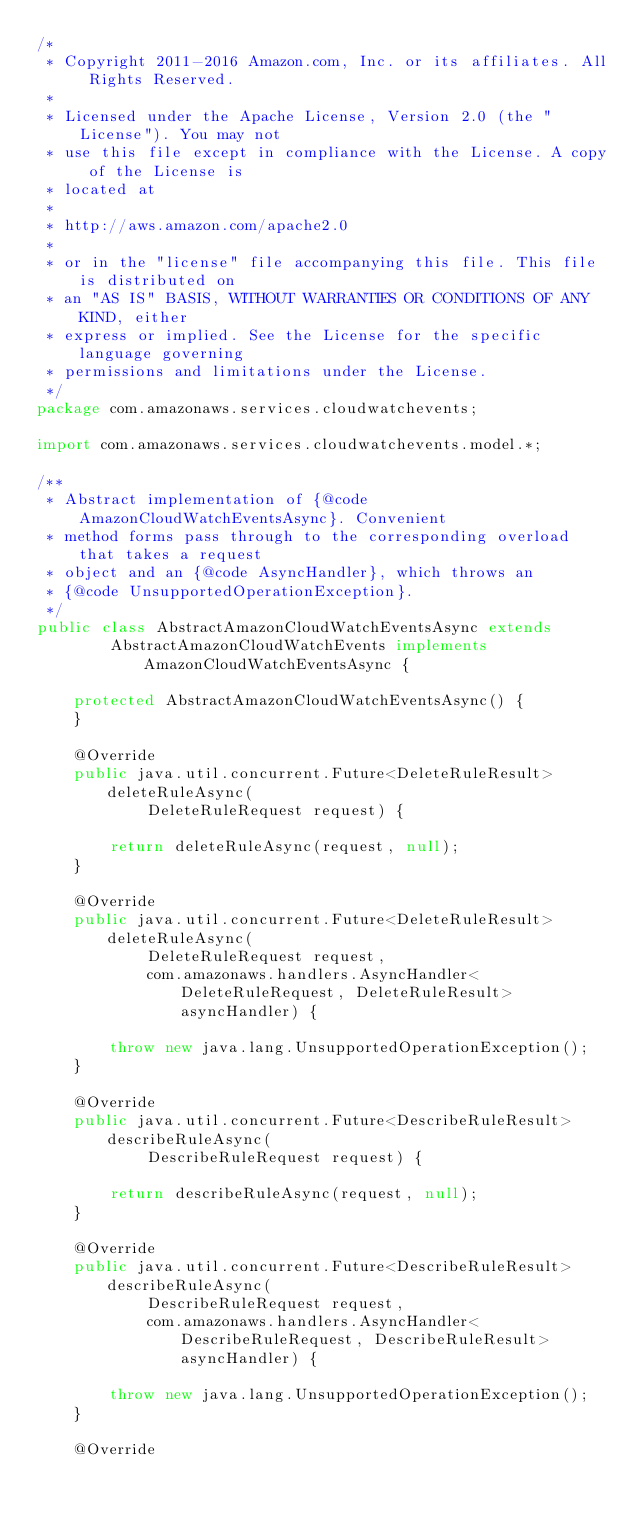Convert code to text. <code><loc_0><loc_0><loc_500><loc_500><_Java_>/*
 * Copyright 2011-2016 Amazon.com, Inc. or its affiliates. All Rights Reserved.
 * 
 * Licensed under the Apache License, Version 2.0 (the "License"). You may not
 * use this file except in compliance with the License. A copy of the License is
 * located at
 * 
 * http://aws.amazon.com/apache2.0
 * 
 * or in the "license" file accompanying this file. This file is distributed on
 * an "AS IS" BASIS, WITHOUT WARRANTIES OR CONDITIONS OF ANY KIND, either
 * express or implied. See the License for the specific language governing
 * permissions and limitations under the License.
 */
package com.amazonaws.services.cloudwatchevents;

import com.amazonaws.services.cloudwatchevents.model.*;

/**
 * Abstract implementation of {@code AmazonCloudWatchEventsAsync}. Convenient
 * method forms pass through to the corresponding overload that takes a request
 * object and an {@code AsyncHandler}, which throws an
 * {@code UnsupportedOperationException}.
 */
public class AbstractAmazonCloudWatchEventsAsync extends
        AbstractAmazonCloudWatchEvents implements AmazonCloudWatchEventsAsync {

    protected AbstractAmazonCloudWatchEventsAsync() {
    }

    @Override
    public java.util.concurrent.Future<DeleteRuleResult> deleteRuleAsync(
            DeleteRuleRequest request) {

        return deleteRuleAsync(request, null);
    }

    @Override
    public java.util.concurrent.Future<DeleteRuleResult> deleteRuleAsync(
            DeleteRuleRequest request,
            com.amazonaws.handlers.AsyncHandler<DeleteRuleRequest, DeleteRuleResult> asyncHandler) {

        throw new java.lang.UnsupportedOperationException();
    }

    @Override
    public java.util.concurrent.Future<DescribeRuleResult> describeRuleAsync(
            DescribeRuleRequest request) {

        return describeRuleAsync(request, null);
    }

    @Override
    public java.util.concurrent.Future<DescribeRuleResult> describeRuleAsync(
            DescribeRuleRequest request,
            com.amazonaws.handlers.AsyncHandler<DescribeRuleRequest, DescribeRuleResult> asyncHandler) {

        throw new java.lang.UnsupportedOperationException();
    }

    @Override</code> 